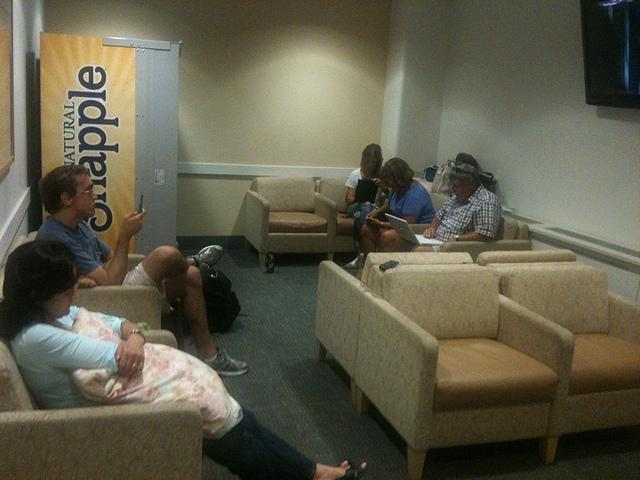What sort of beverages are most readily available here? Please explain your reasoning. iced tea. A snapple machine is in a waiting room. snapple makes tea. 